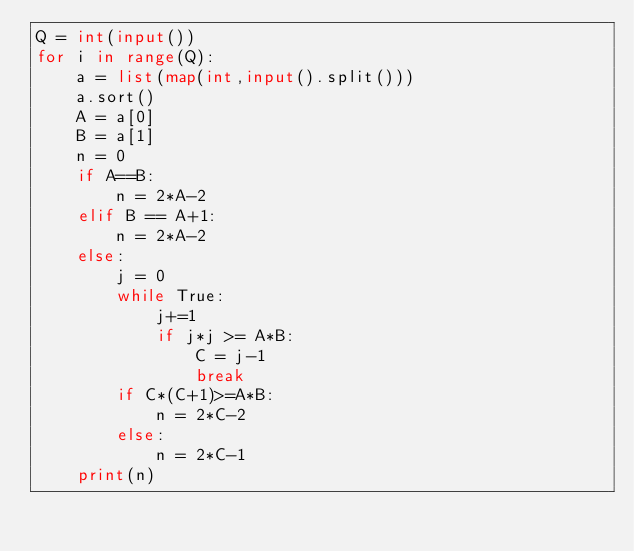<code> <loc_0><loc_0><loc_500><loc_500><_Python_>Q = int(input())
for i in range(Q):
    a = list(map(int,input().split()))
    a.sort()
    A = a[0]
    B = a[1]
    n = 0
    if A==B:
        n = 2*A-2
    elif B == A+1:
        n = 2*A-2
    else:
        j = 0
        while True:
            j+=1
            if j*j >= A*B:
                C = j-1
                break
        if C*(C+1)>=A*B:
            n = 2*C-2
        else:
            n = 2*C-1
    print(n)</code> 